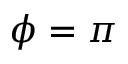Convert formula to latex. <formula><loc_0><loc_0><loc_500><loc_500>\phi = \pi</formula> 